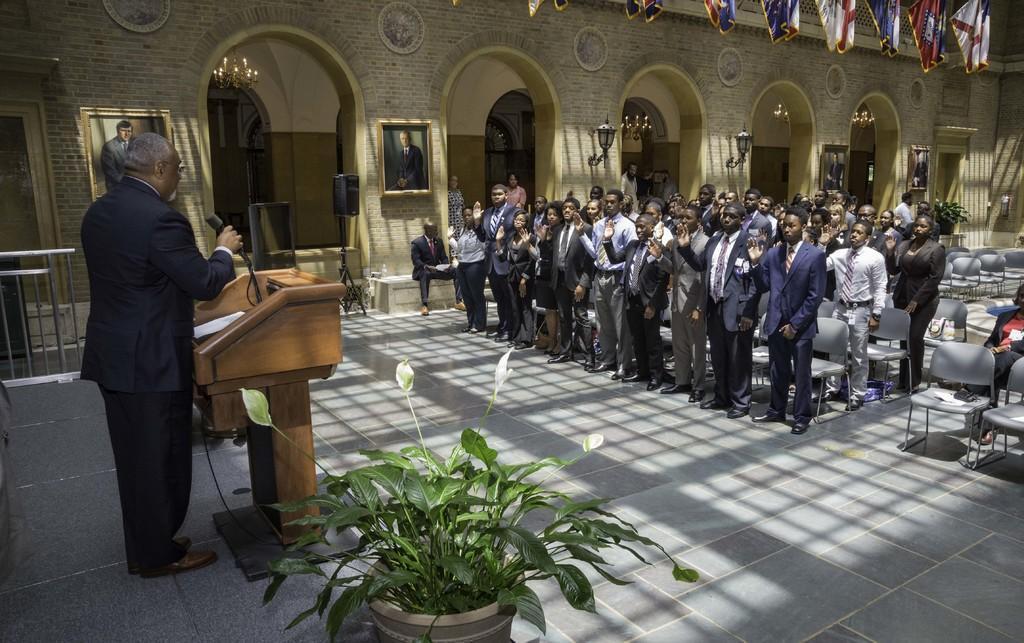How would you summarize this image in a sentence or two? In this image we can see a person standing near a podium. There is a plant. To the right side of the image there are people standing. There are chairs. In the background of the image there are photo frames on the walls. There are lights. At the top of the image there are flags. At the bottom of the image there is floor. 